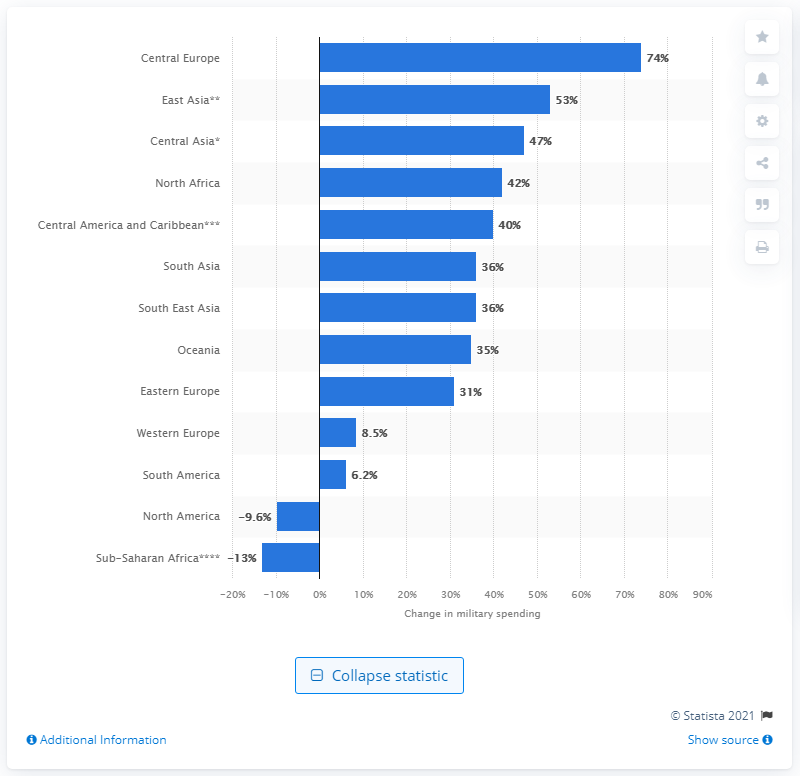List a handful of essential elements in this visual. Western Europe's military spending increased by 8.5% between 2011 and 2020. The military expenditures of Central Europe increased by 74% between 2011 and 2020. 